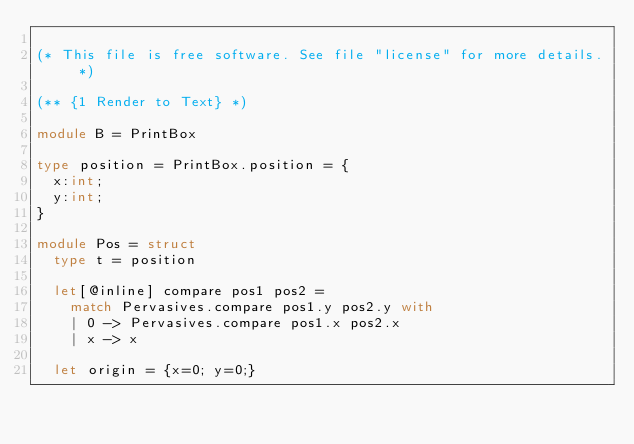<code> <loc_0><loc_0><loc_500><loc_500><_OCaml_>
(* This file is free software. See file "license" for more details. *)

(** {1 Render to Text} *)

module B = PrintBox

type position = PrintBox.position = {
  x:int;
  y:int;
}

module Pos = struct
  type t = position

  let[@inline] compare pos1 pos2 =
    match Pervasives.compare pos1.y pos2.y with
    | 0 -> Pervasives.compare pos1.x pos2.x
    | x -> x

  let origin = {x=0; y=0;}
</code> 